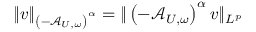Convert formula to latex. <formula><loc_0><loc_0><loc_500><loc_500>\| v \| _ { \left ( - \mathcal { A } _ { U , \omega } \right ) ^ { \alpha } } = \| \left ( - \mathcal { A } _ { U , \omega } \right ) ^ { \alpha } v \| _ { L ^ { p } }</formula> 